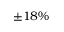Convert formula to latex. <formula><loc_0><loc_0><loc_500><loc_500>\pm 1 8 \%</formula> 